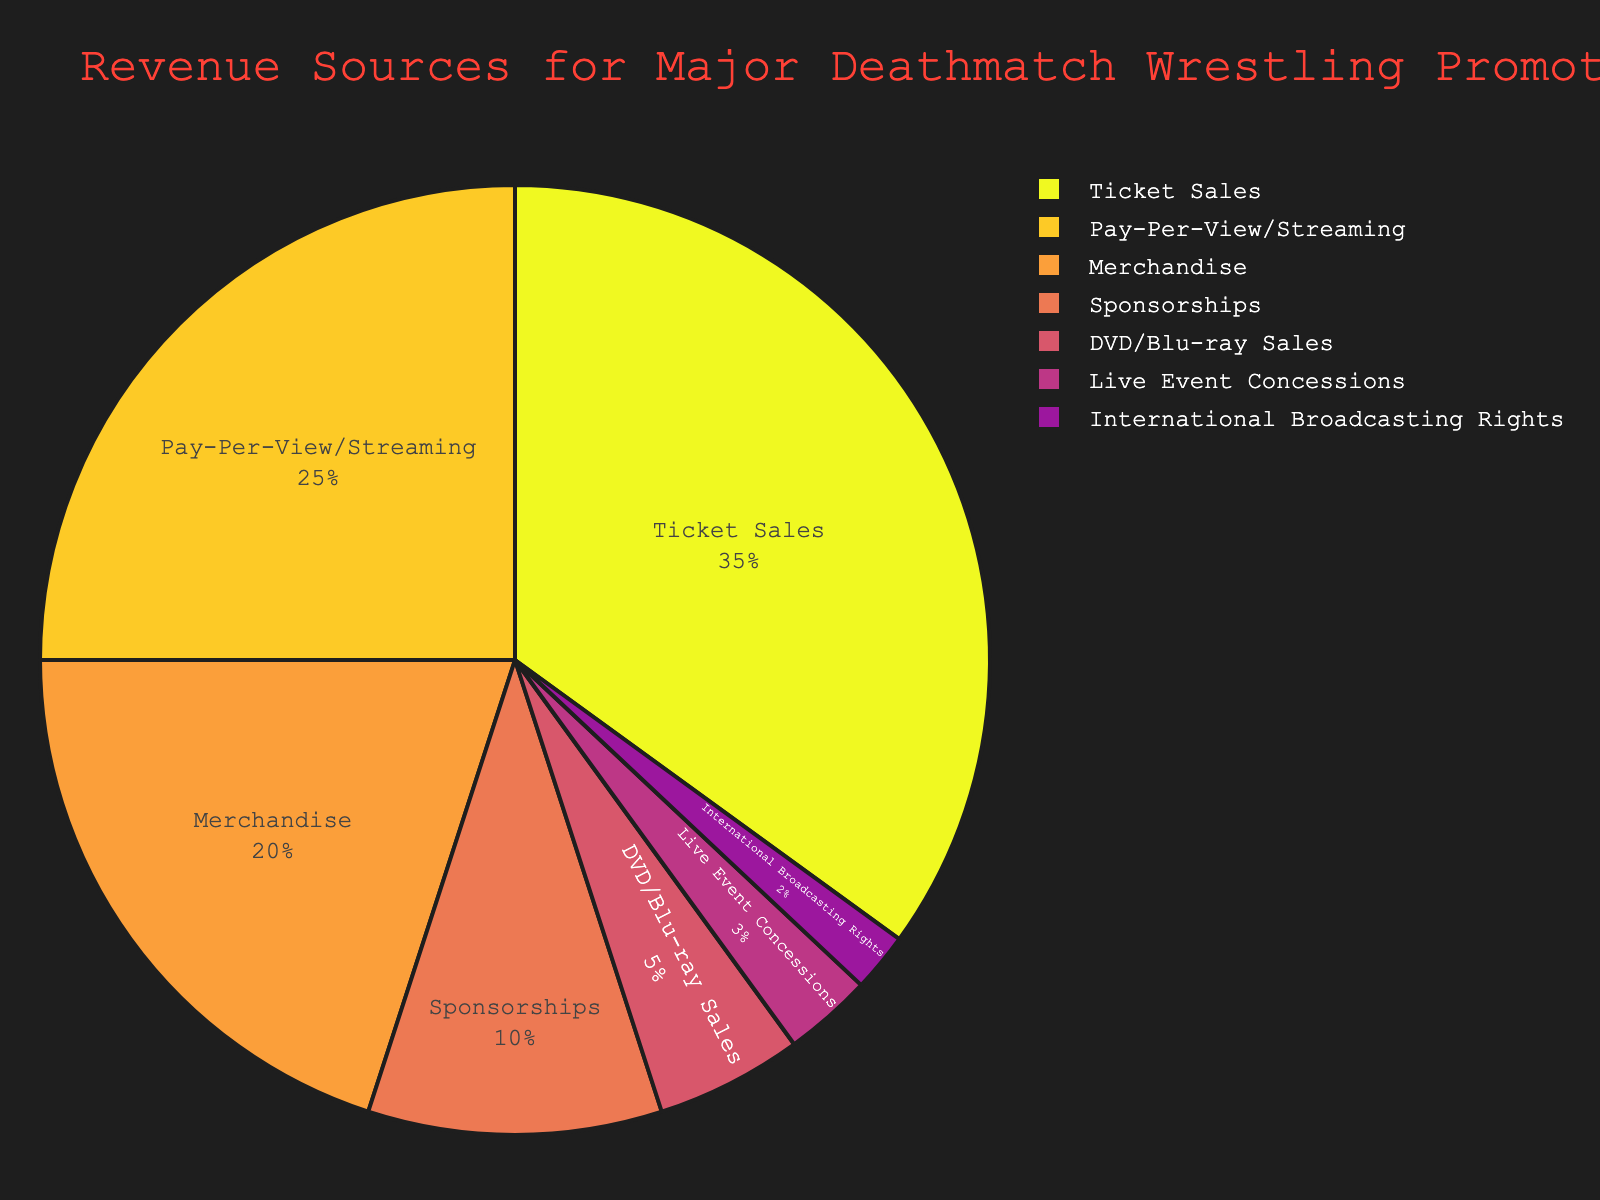What is the largest source of revenue for major Deathmatch Wrestling promotions in Japan? The pie chart shows that "Ticket Sales" occupies the largest section. This indicates that this category contributes the highest percentage of revenue.
Answer: Ticket Sales Which revenue source has a percentage that is equal to the sum of "Live Event Concessions" and "International Broadcasting Rights"? According to the chart, "Live Event Concessions" is 3% and "International Broadcasting Rights" is 2%. Summing these gives 3% + 2% = 5%, which matches the percentage of "DVD/Blu-ray Sales".
Answer: DVD/Blu-ray Sales Between "Pay-Per-View/Streaming" and "Merchandise", which one has a higher contribution to the revenue, and by what percentage? "Pay-Per-View/Streaming" is 25% and "Merchandise" is 20%. The difference can be calculated as 25% - 20% = 5%.
Answer: Pay-Per-View/Streaming, 5% What percentage of the total revenue comes from sources other than "Ticket Sales" and "Pay-Per-View/Streaming"? The percentage of revenue from "Ticket Sales" is 35% and "Pay-Per-View/Streaming" is 25%. The total from other sources is 100% - 35% - 25% = 40%.
Answer: 40% Does the combined revenue from "Sponsorships" and "Live Event Concessions" surpass the revenue from "Merchandise"? "Sponsorships" contribute 10% and "Live Event Concessions" contribute 3%, giving a combined total of 10% + 3% = 13%, which does not surpass the 20% from "Merchandise".
Answer: No Which category contributes the least to the revenue, and what is its percentage? The smallest segment in the pie chart is for "International Broadcasting Rights", which contributes 2% of the revenue.
Answer: International Broadcasting Rights, 2% If "Ticket Sales" were to decrease by 5%, what would their new percentage be, and would they still be the largest revenue source? If "Ticket Sales" decrease by 5% from 35%, the new percentage would be 35% - 5% = 30%. The next highest category is "Pay-Per-View/Streaming" at 25%, so "Ticket Sales" would still be the largest source.
Answer: 30%, Yes 